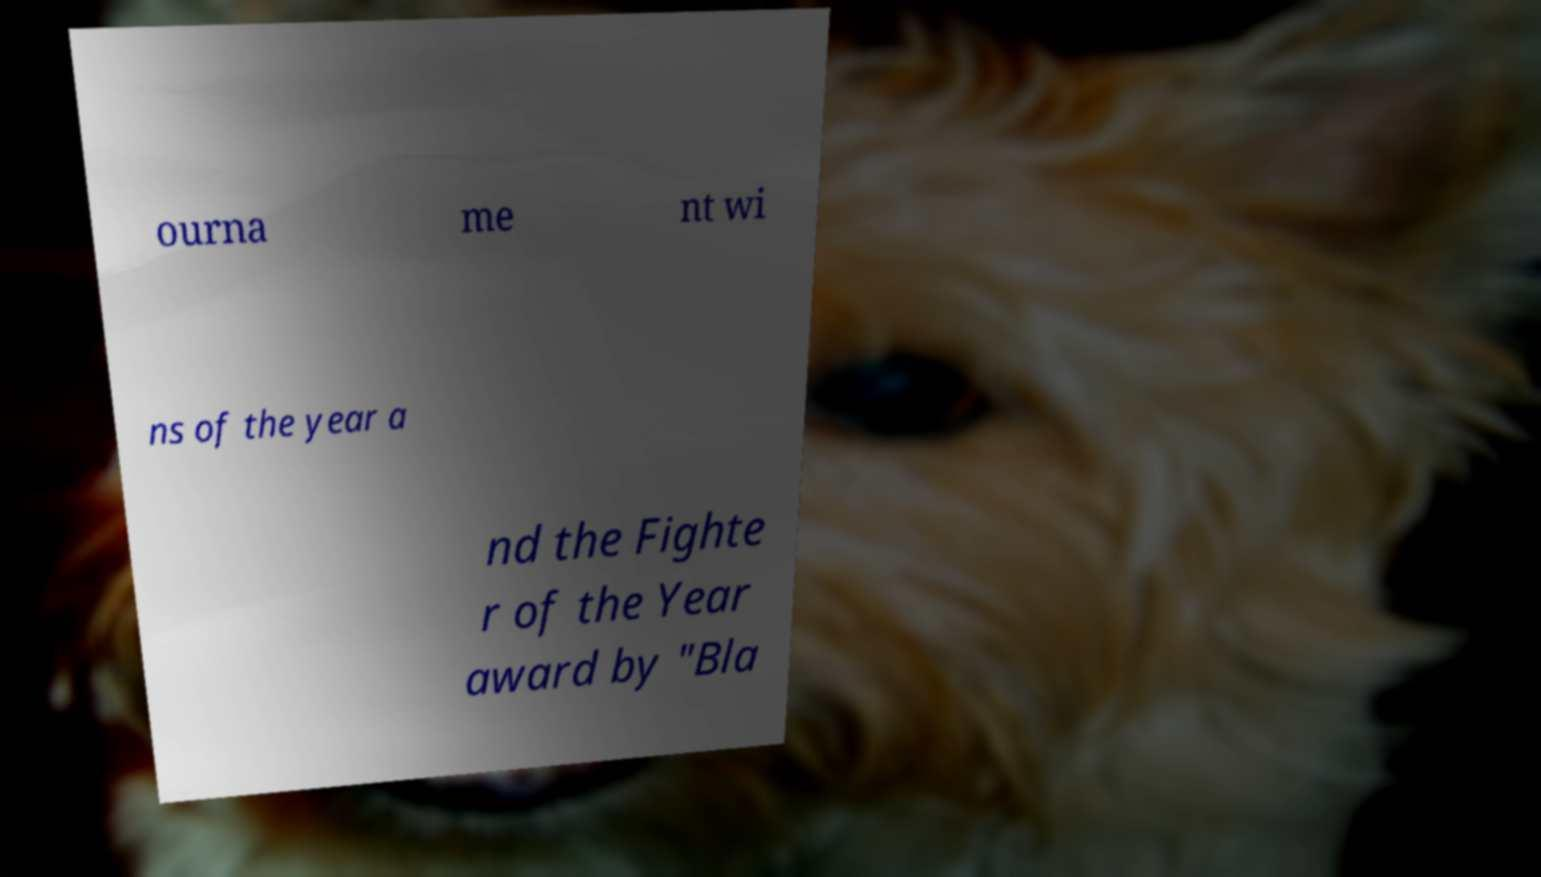Can you accurately transcribe the text from the provided image for me? ourna me nt wi ns of the year a nd the Fighte r of the Year award by "Bla 